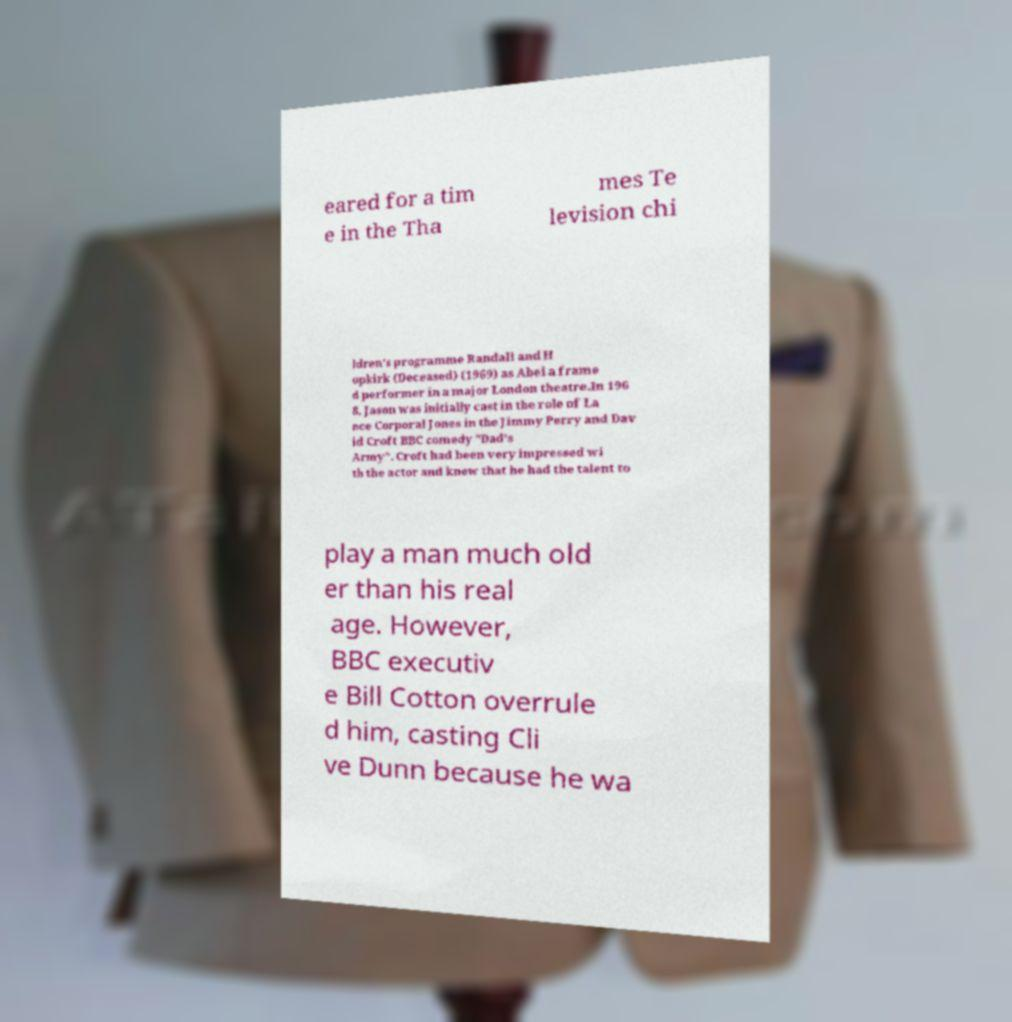Can you read and provide the text displayed in the image?This photo seems to have some interesting text. Can you extract and type it out for me? eared for a tim e in the Tha mes Te levision chi ldren's programme Randall and H opkirk (Deceased) (1969) as Abel a frame d performer in a major London theatre.In 196 8, Jason was initially cast in the role of La nce Corporal Jones in the Jimmy Perry and Dav id Croft BBC comedy "Dad's Army". Croft had been very impressed wi th the actor and knew that he had the talent to play a man much old er than his real age. However, BBC executiv e Bill Cotton overrule d him, casting Cli ve Dunn because he wa 